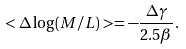Convert formula to latex. <formula><loc_0><loc_0><loc_500><loc_500>< \Delta \log ( M / L ) > = - \frac { \Delta \gamma } { 2 . 5 \beta } .</formula> 